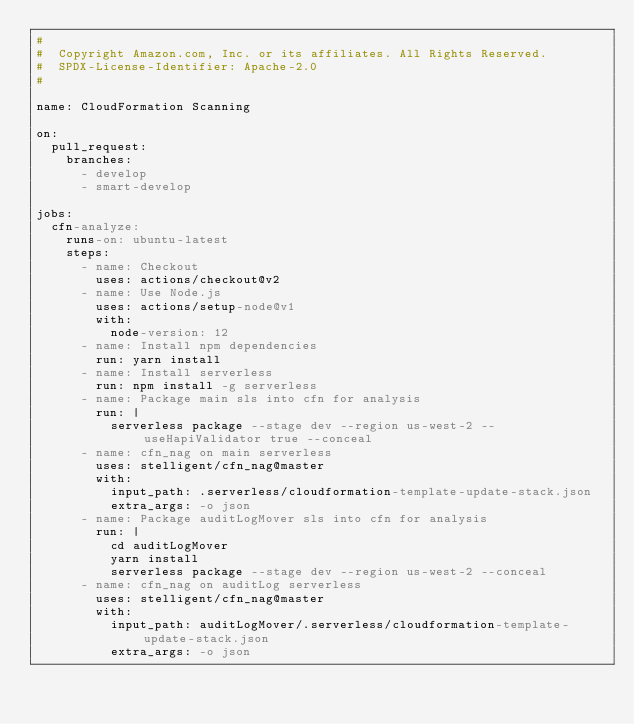Convert code to text. <code><loc_0><loc_0><loc_500><loc_500><_YAML_>#
#  Copyright Amazon.com, Inc. or its affiliates. All Rights Reserved.
#  SPDX-License-Identifier: Apache-2.0
#

name: CloudFormation Scanning

on:
  pull_request:
    branches:
      - develop
      - smart-develop

jobs:
  cfn-analyze:
    runs-on: ubuntu-latest
    steps:
      - name: Checkout
        uses: actions/checkout@v2
      - name: Use Node.js
        uses: actions/setup-node@v1
        with:
          node-version: 12
      - name: Install npm dependencies
        run: yarn install
      - name: Install serverless
        run: npm install -g serverless
      - name: Package main sls into cfn for analysis
        run: |
          serverless package --stage dev --region us-west-2 --useHapiValidator true --conceal
      - name: cfn_nag on main serverless
        uses: stelligent/cfn_nag@master
        with:
          input_path: .serverless/cloudformation-template-update-stack.json
          extra_args: -o json  
      - name: Package auditLogMover sls into cfn for analysis
        run: |
          cd auditLogMover
          yarn install
          serverless package --stage dev --region us-west-2 --conceal
      - name: cfn_nag on auditLog serverless
        uses: stelligent/cfn_nag@master
        with:
          input_path: auditLogMover/.serverless/cloudformation-template-update-stack.json
          extra_args: -o json
</code> 